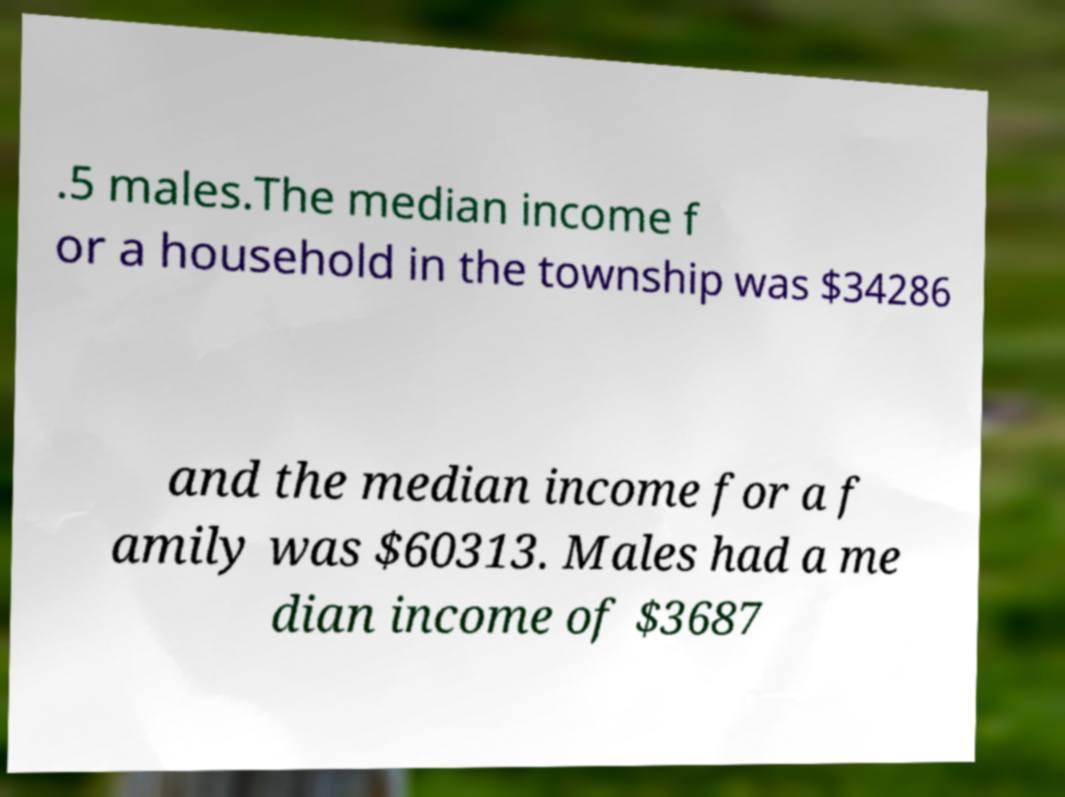Can you accurately transcribe the text from the provided image for me? .5 males.The median income f or a household in the township was $34286 and the median income for a f amily was $60313. Males had a me dian income of $3687 